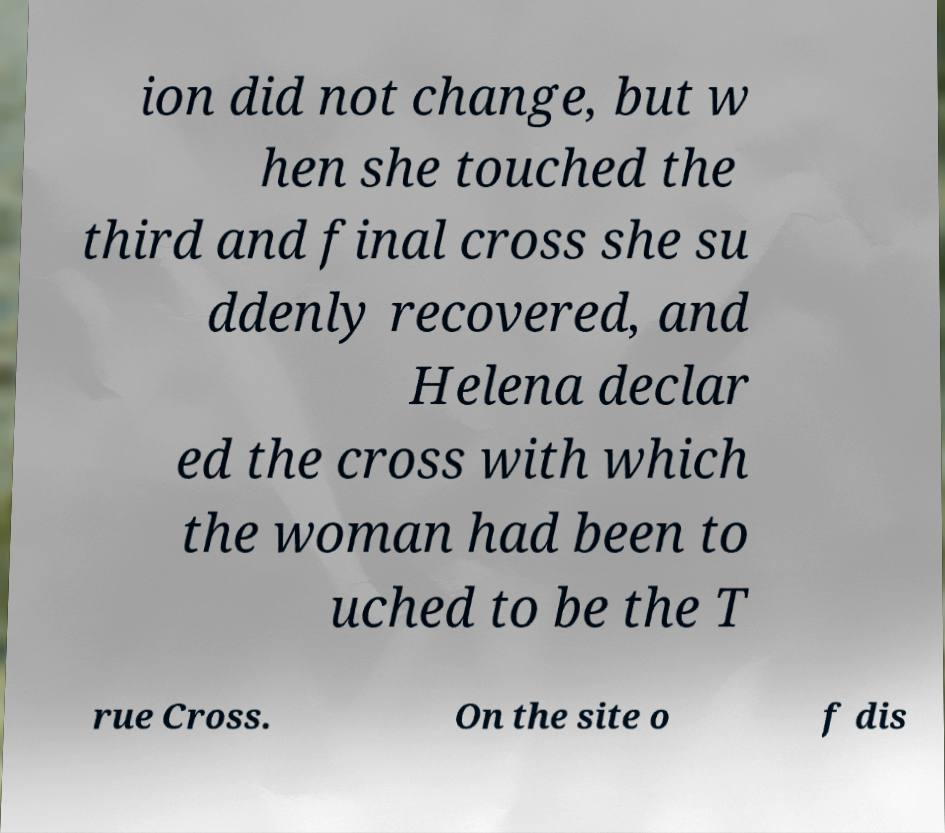Could you extract and type out the text from this image? ion did not change, but w hen she touched the third and final cross she su ddenly recovered, and Helena declar ed the cross with which the woman had been to uched to be the T rue Cross. On the site o f dis 